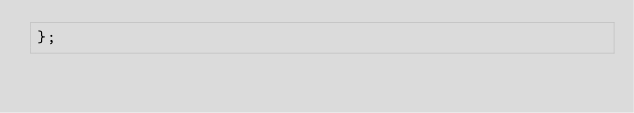<code> <loc_0><loc_0><loc_500><loc_500><_JavaScript_>};
</code> 